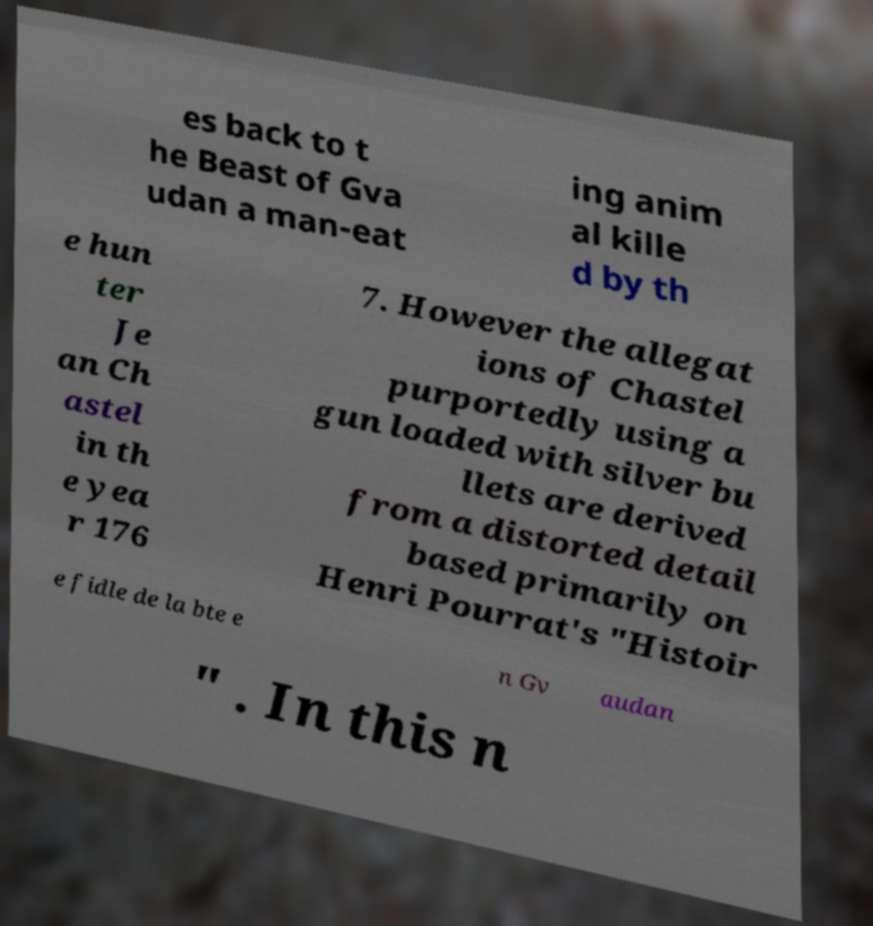I need the written content from this picture converted into text. Can you do that? es back to t he Beast of Gva udan a man-eat ing anim al kille d by th e hun ter Je an Ch astel in th e yea r 176 7. However the allegat ions of Chastel purportedly using a gun loaded with silver bu llets are derived from a distorted detail based primarily on Henri Pourrat's "Histoir e fidle de la bte e n Gv audan " . In this n 